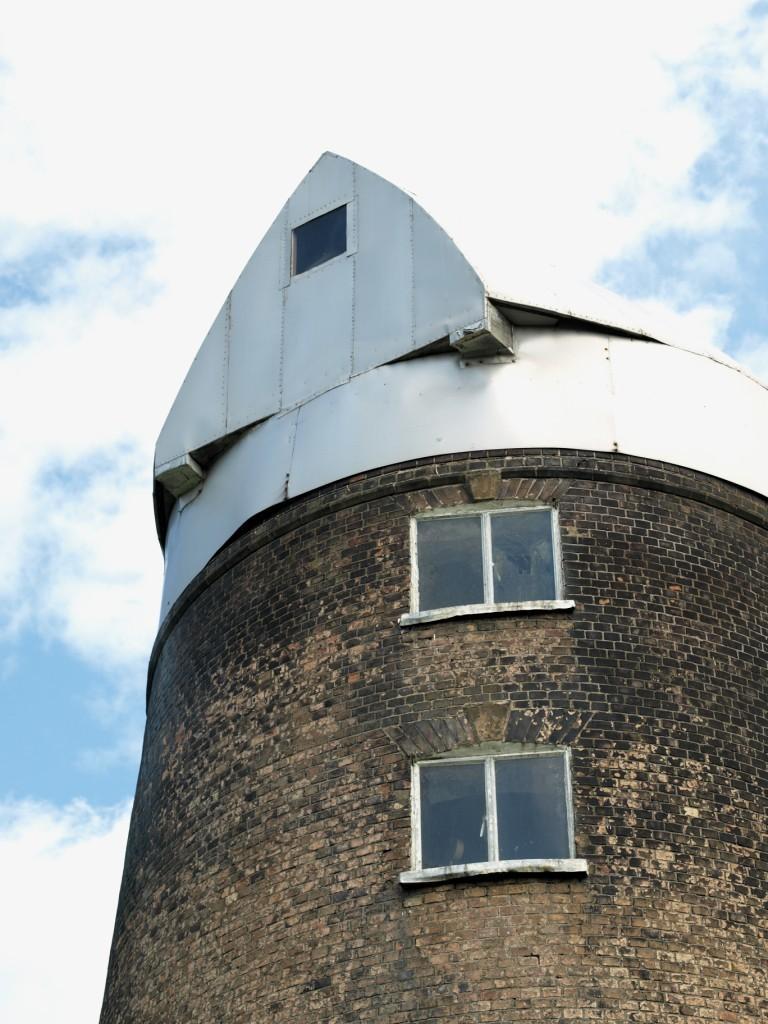Describe this image in one or two sentences. This image is taken outdoors. At the top of the image there is the sky with clouds. On the right side of the image there is a building with walls, windows and a roof. 